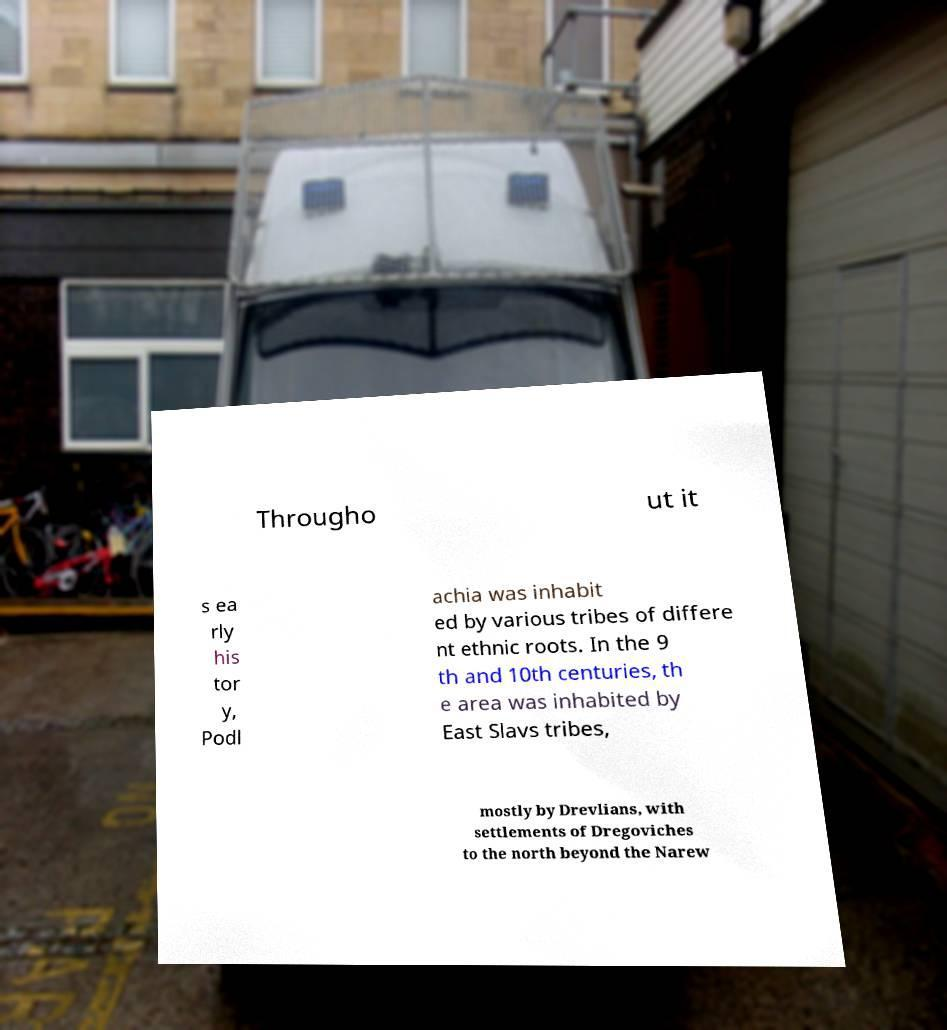There's text embedded in this image that I need extracted. Can you transcribe it verbatim? Througho ut it s ea rly his tor y, Podl achia was inhabit ed by various tribes of differe nt ethnic roots. In the 9 th and 10th centuries, th e area was inhabited by East Slavs tribes, mostly by Drevlians, with settlements of Dregoviches to the north beyond the Narew 